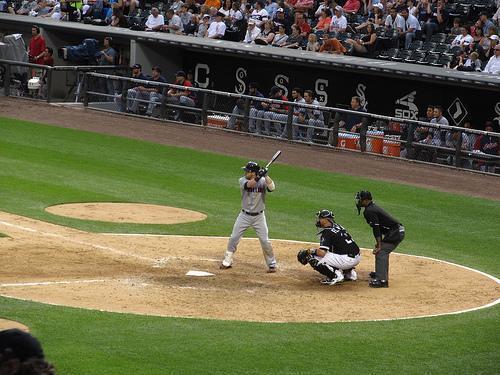How many baseball bats are visible?
Give a very brief answer. 1. How many baseball players are visible?
Give a very brief answer. 3. How many baseball players are wearing face masks?
Give a very brief answer. 2. 